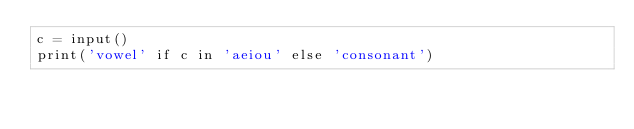<code> <loc_0><loc_0><loc_500><loc_500><_Python_>c = input()
print('vowel' if c in 'aeiou' else 'consonant')
</code> 